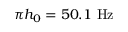<formula> <loc_0><loc_0><loc_500><loc_500>\pi h _ { 0 } = 5 0 . 1 H z</formula> 